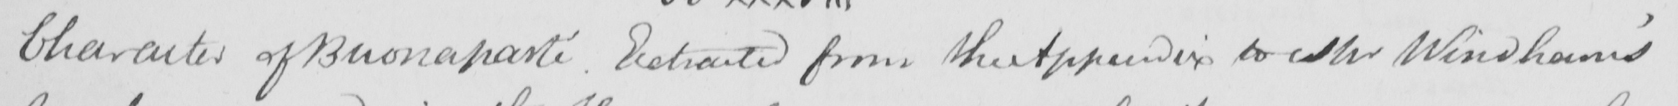Can you read and transcribe this handwriting? Character of Buonaparte . Extracted from the Appendix to Mr Windham ' s 